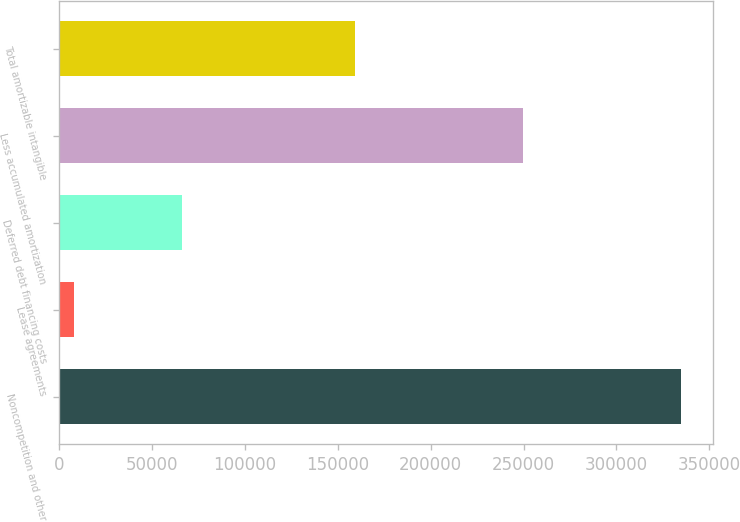Convert chart. <chart><loc_0><loc_0><loc_500><loc_500><bar_chart><fcel>Noncompetition and other<fcel>Lease agreements<fcel>Deferred debt financing costs<fcel>Less accumulated amortization<fcel>Total amortizable intangible<nl><fcel>335012<fcel>8081<fcel>66011<fcel>249613<fcel>159491<nl></chart> 